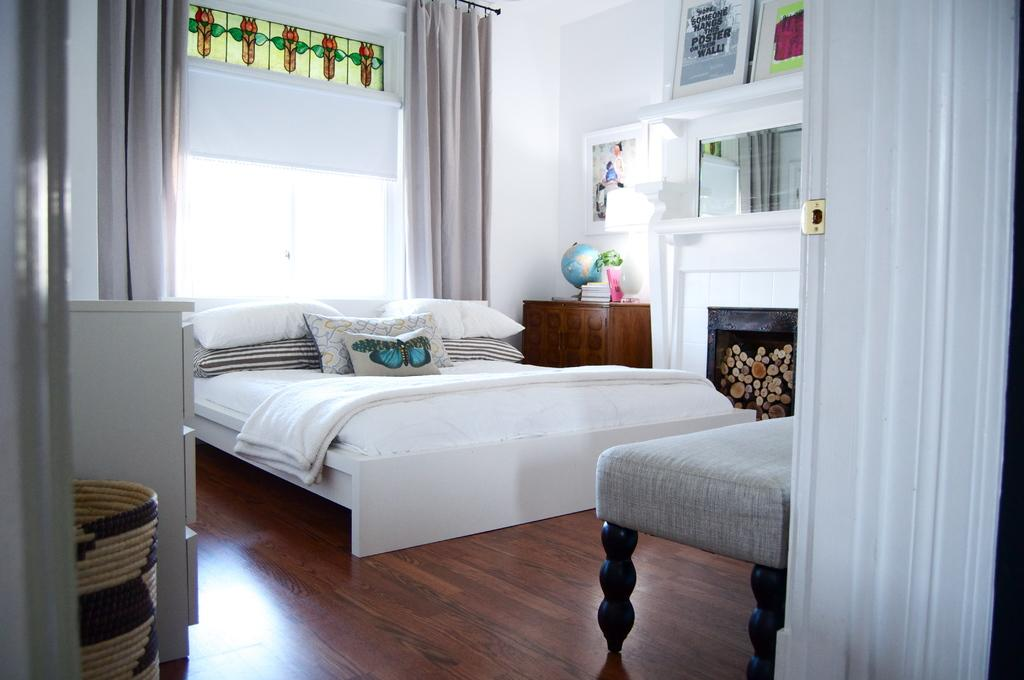What type of room is depicted in the image? The image shows an inner view of a bedroom. What is the main piece of furniture in the bedroom? There is a bed in the room. Are there any accessories on the bed? Yes, there are pillows on the bed. What can be seen on the wall in the bedroom? There are photo frames on the wall. What type of meat is hanging from the ceiling in the image? There is no meat present in the image; it shows an inner view of a bedroom with a bed, pillows, and photo frames on the wall. 